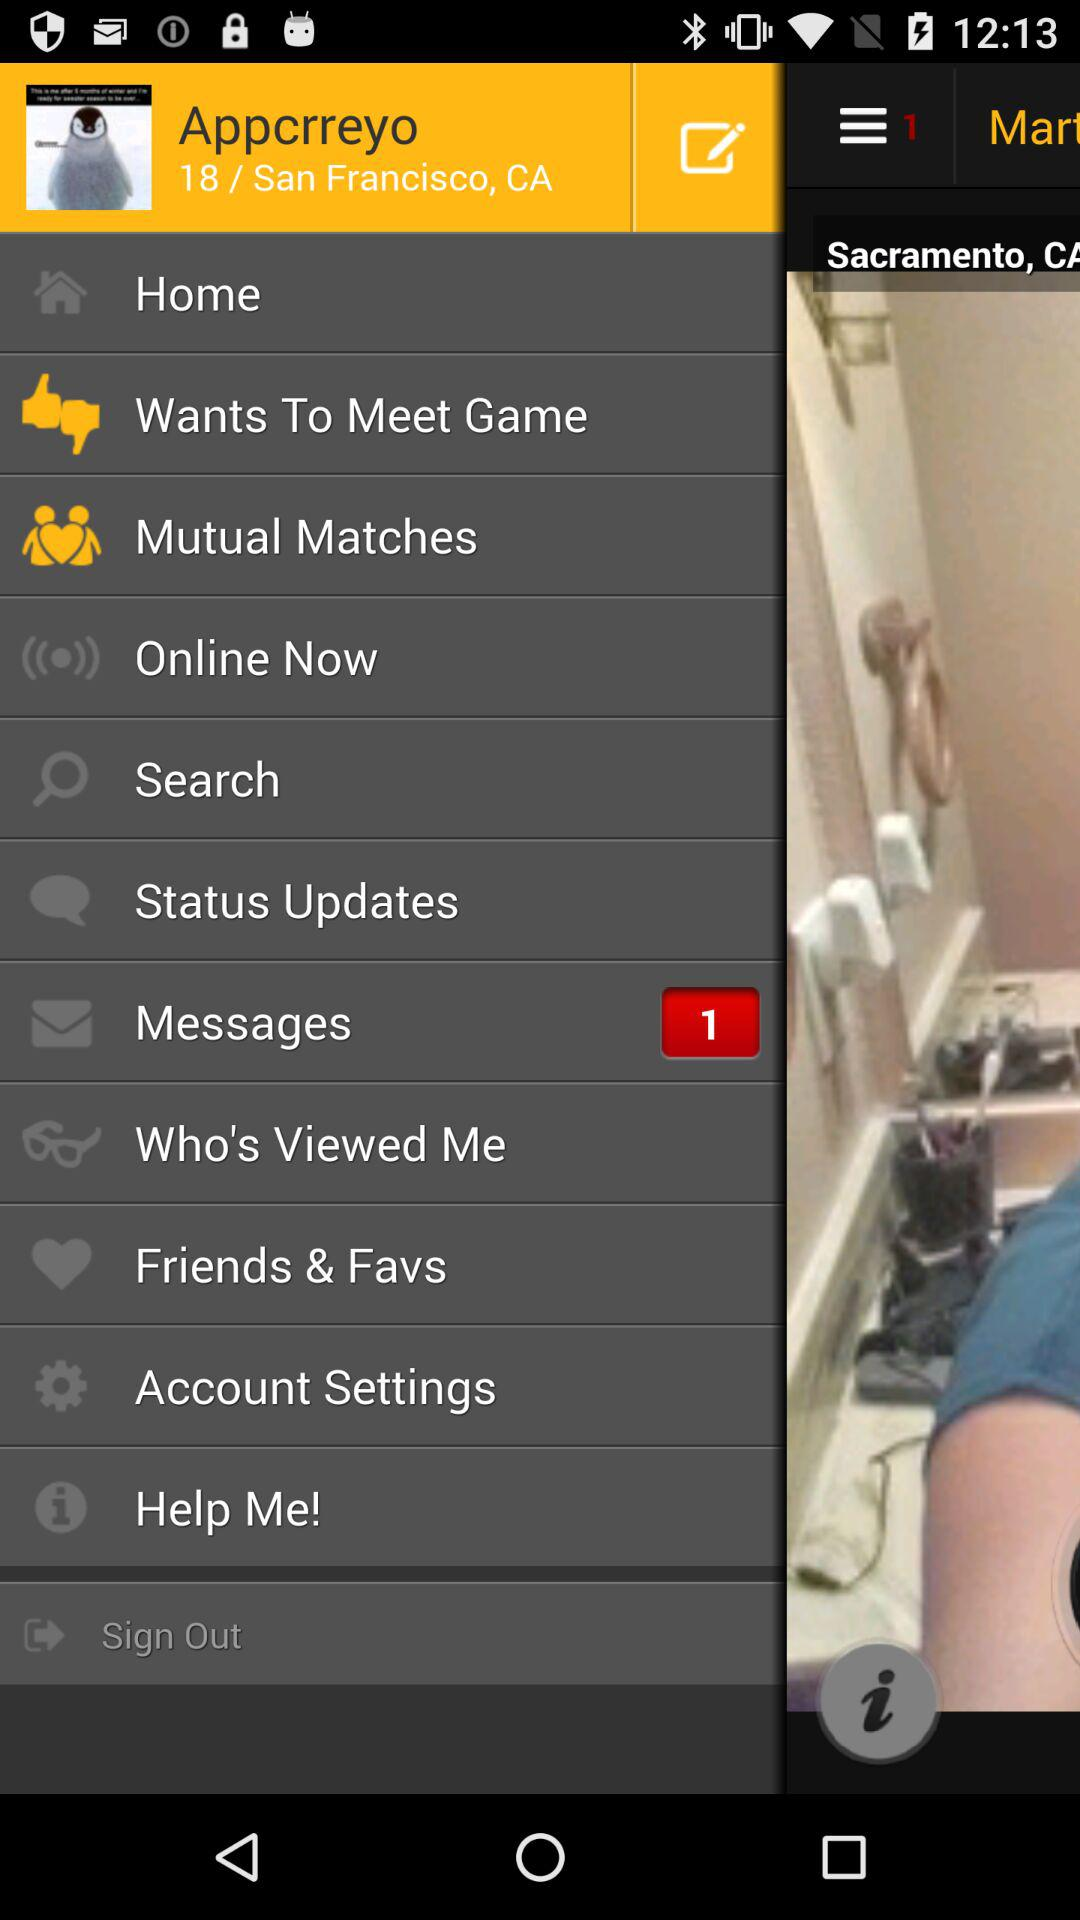Which option is highlighted?
When the provided information is insufficient, respond with <no answer>. <no answer> 